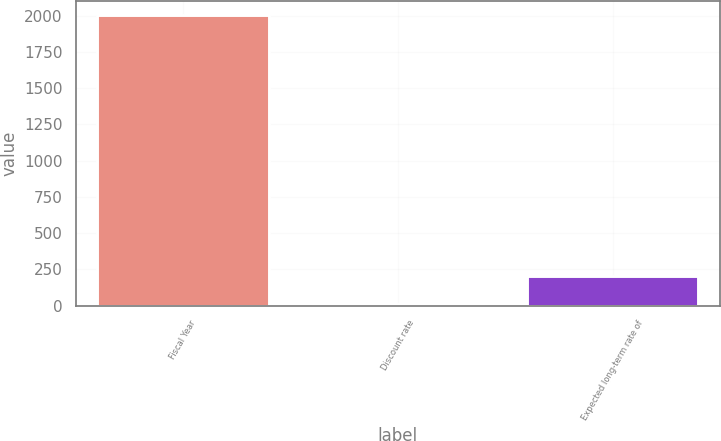Convert chart. <chart><loc_0><loc_0><loc_500><loc_500><bar_chart><fcel>Fiscal Year<fcel>Discount rate<fcel>Expected long-term rate of<nl><fcel>2003<fcel>7.5<fcel>207.05<nl></chart> 